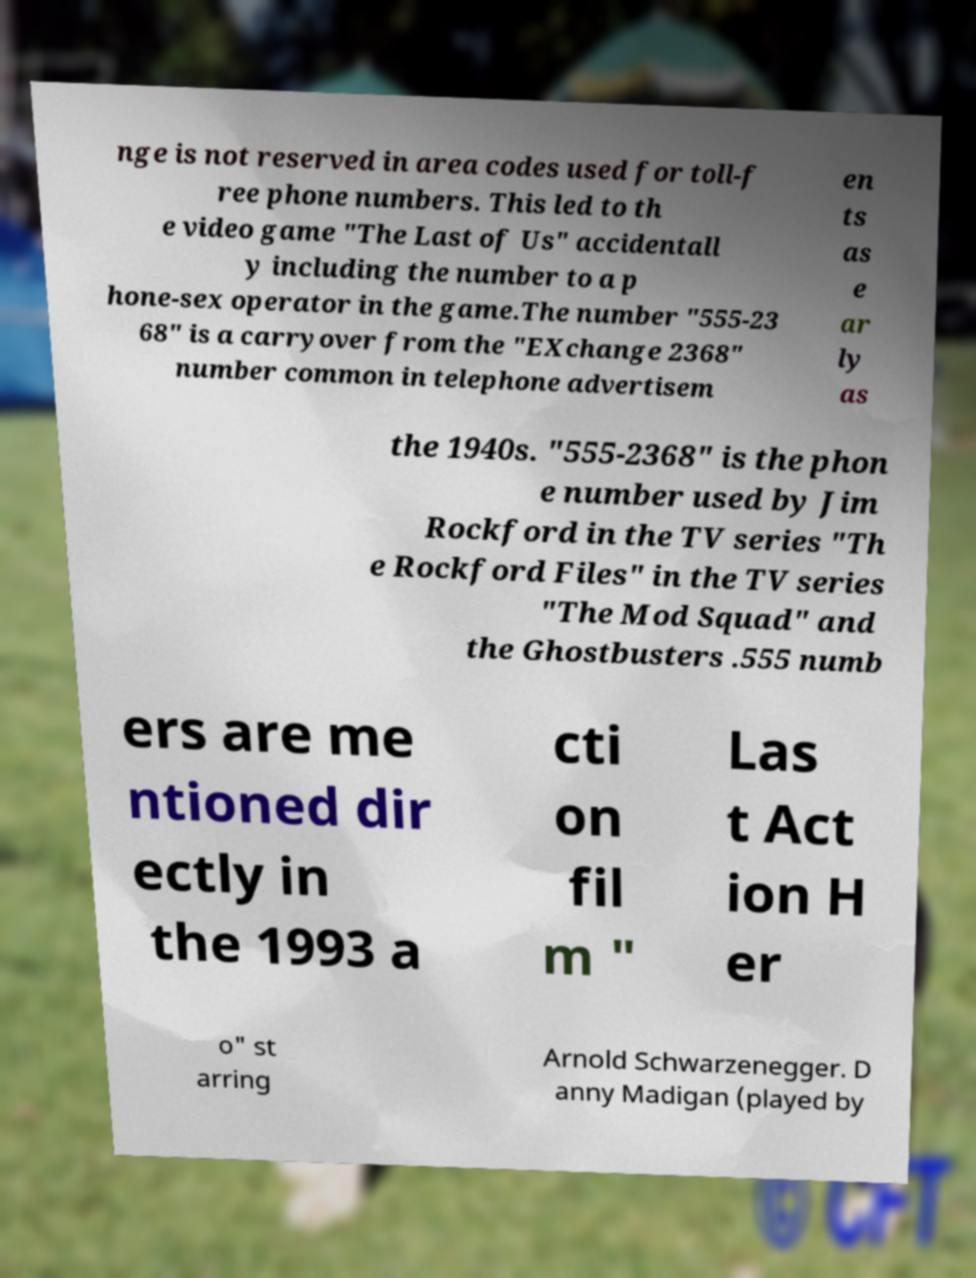Could you extract and type out the text from this image? nge is not reserved in area codes used for toll-f ree phone numbers. This led to th e video game "The Last of Us" accidentall y including the number to a p hone-sex operator in the game.The number "555-23 68" is a carryover from the "EXchange 2368" number common in telephone advertisem en ts as e ar ly as the 1940s. "555-2368" is the phon e number used by Jim Rockford in the TV series "Th e Rockford Files" in the TV series "The Mod Squad" and the Ghostbusters .555 numb ers are me ntioned dir ectly in the 1993 a cti on fil m " Las t Act ion H er o" st arring Arnold Schwarzenegger. D anny Madigan (played by 